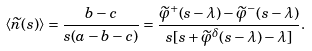Convert formula to latex. <formula><loc_0><loc_0><loc_500><loc_500>\langle \widetilde { n } ( s ) \rangle = \frac { b - c } { s ( a - b - c ) } = \frac { \widetilde { \varphi } ^ { + } ( s - \lambda ) - \widetilde { \varphi } ^ { - } ( s - \lambda ) } { s [ s + \widetilde { \varphi } ^ { \delta } ( s - \lambda ) - \lambda ] } .</formula> 